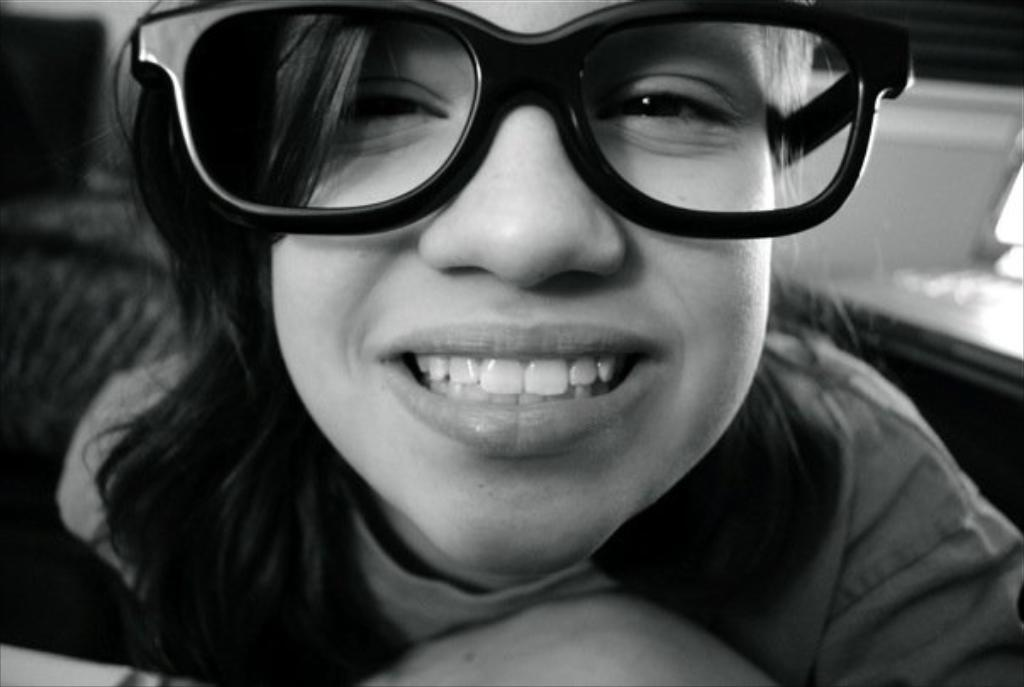What is the color scheme of the image? The image is black and white. Who or what is the main subject in the image? There is a girl in the image. What accessory is the girl wearing? The girl is wearing glasses. What type of cheese is being used as a prop by the actor in the image? There is no actor or cheese present in the image; it features a girl wearing glasses in a black and white setting. 